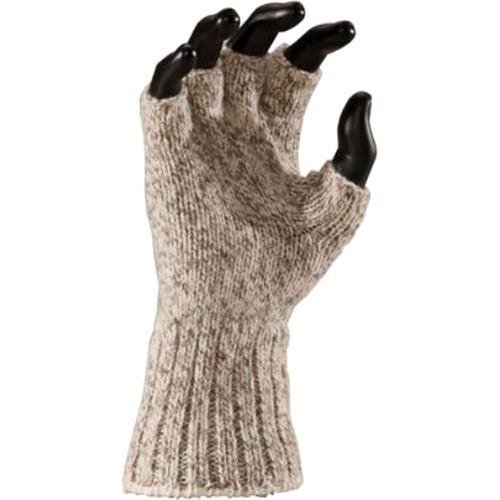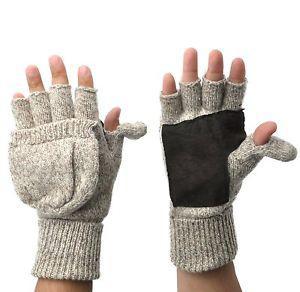The first image is the image on the left, the second image is the image on the right. Given the left and right images, does the statement "a mannequin's hand is wearing a glove." hold true? Answer yes or no. Yes. The first image is the image on the left, the second image is the image on the right. Analyze the images presented: Is the assertion "A fingerless glove in a taupe color with ribbed detailing in the wrist section is modeled in one image by a black hand mannequin." valid? Answer yes or no. Yes. 